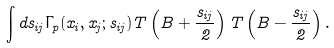Convert formula to latex. <formula><loc_0><loc_0><loc_500><loc_500>\int d s _ { i j } \Gamma _ { p } ( x _ { i } , x _ { j } ; s _ { i j } ) T \left ( B + \frac { s _ { i j } } { 2 } \right ) T \left ( B - \frac { s _ { i j } } { 2 } \right ) .</formula> 